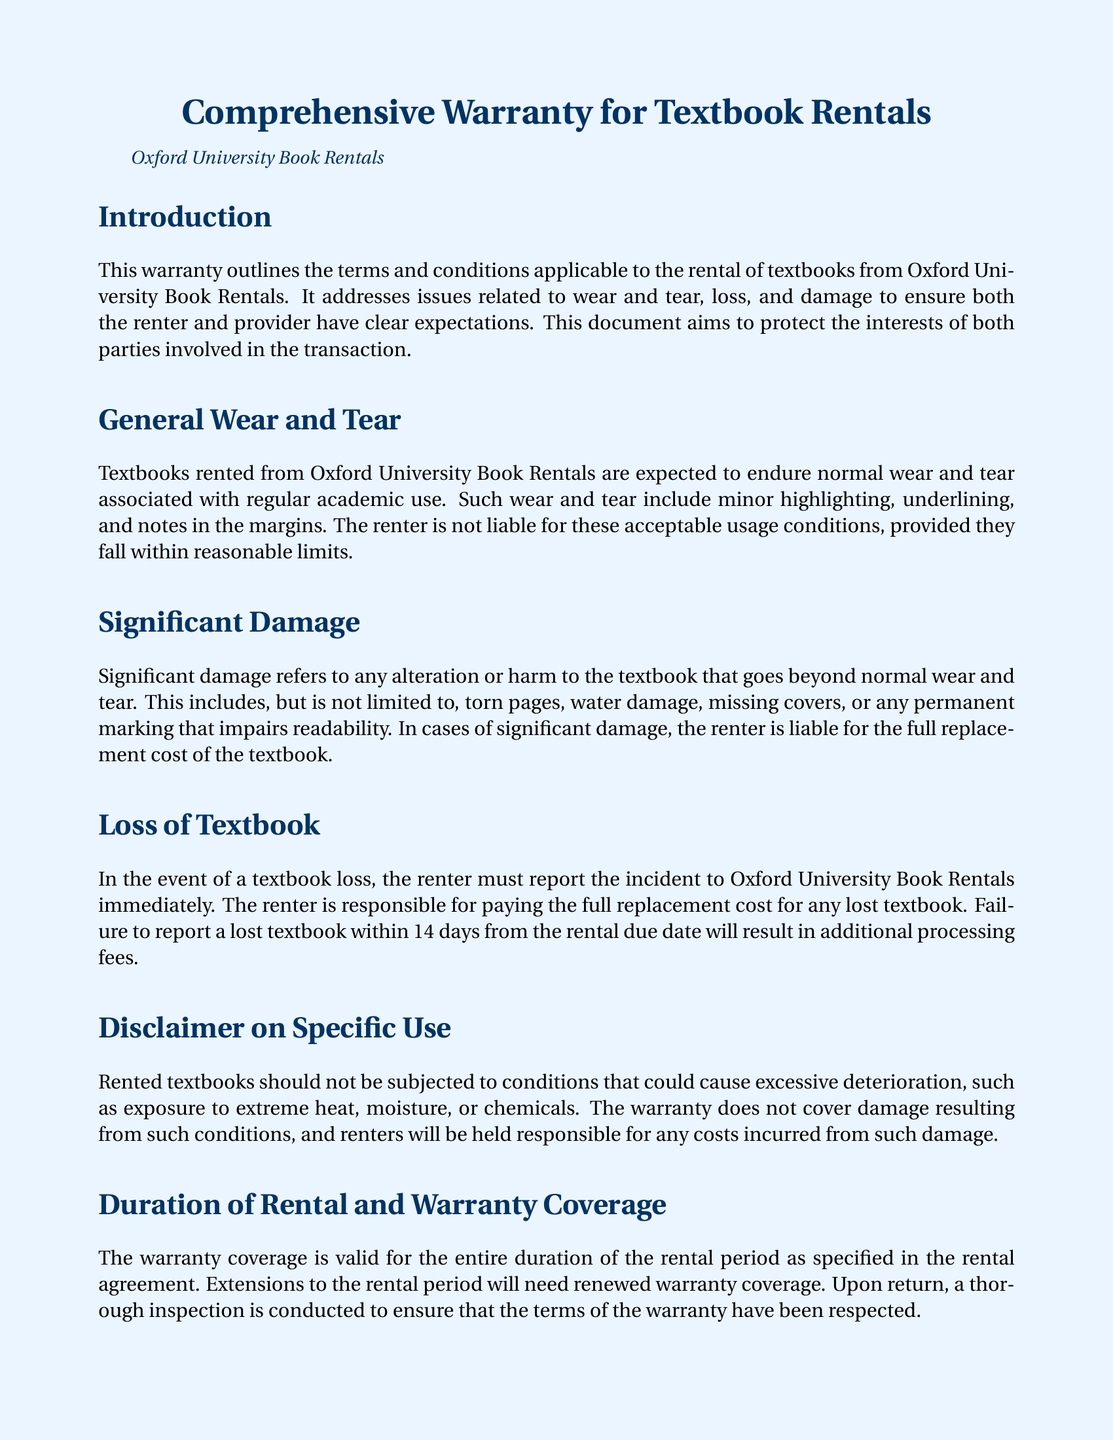what is the title of the document? The title of the document is presented clearly at the top.
Answer: Comprehensive Warranty for Textbook Rentals who issues this warranty? The warranty specifies that it is provided by a specific organization.
Answer: Oxford University Book Rentals what constitutes "normal wear and tear"? The document lists specific examples that fall under this category.
Answer: Minor highlighting, underlining, and notes in the margins what is the renter's responsibility upon loss of a textbook? This is clearly stated regarding actions the renter must take in case of loss.
Answer: Report the incident immediately how long does the renter have to report a lost textbook? The warranty sets a specific time frame for reporting.
Answer: 14 days what is the consequence of late returns? The document outlines actions that will be taken for a specific violation.
Answer: Subject to additional fees what does "significant damage" refer to? The warranty explains what types of damage fall under this definition.
Answer: Torn pages, water damage, missing covers for how long is the warranty coverage valid? The warranty specifies a duration related to a contract.
Answer: The entire duration of the rental period who can renters contact for questions or concerns? The document provides contact information for support.
Answer: Oxford University Book Rentals 